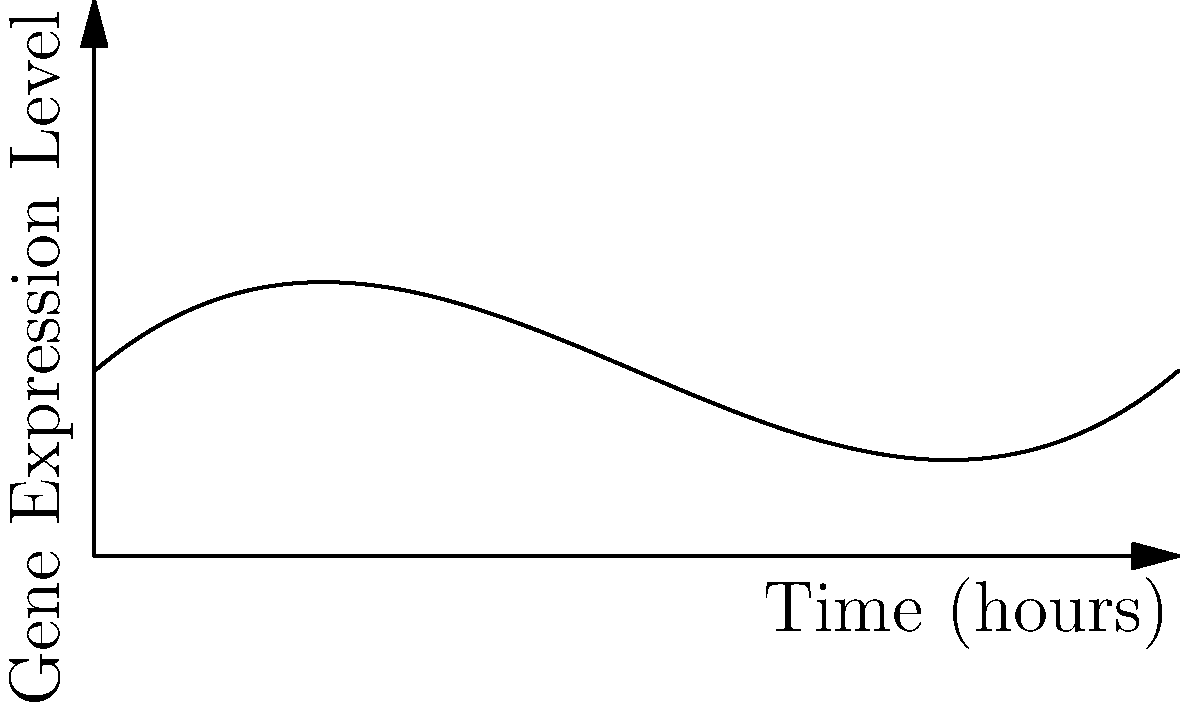The graph represents the expression level of a certain gene over time in a biobank sample. If the expression level at point A is 15 units, what is the approximate expression level at point B? To solve this problem, we need to follow these steps:

1. Understand the graph: The curve represents gene expression levels over time.

2. Identify points A and B:
   - Point A is at approximately 2 hours on the x-axis.
   - Point B is at approximately 8 hours on the x-axis.

3. Note the given information: The expression level at point A is 15 units.

4. Estimate the relative heights of points A and B:
   - Point A appears to be at about 1/2 of the y-axis height.
   - Point B appears to be at about 2/3 of the y-axis height.

5. Calculate the approximate expression level at point B:
   - If 15 units represents 1/2 of the y-axis height, then the full y-axis height is approximately 30 units.
   - Point B is at 2/3 of this height, so:
     $2/3 * 30 = 20$ units

Therefore, the approximate expression level at point B is 20 units.
Answer: 20 units 